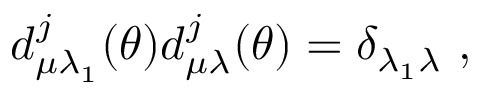<formula> <loc_0><loc_0><loc_500><loc_500>d _ { \mu \lambda _ { 1 } } ^ { j } ( \theta ) d _ { \mu \lambda } ^ { j } ( \theta ) = \delta _ { \lambda _ { 1 } \lambda } \ ,</formula> 